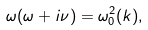<formula> <loc_0><loc_0><loc_500><loc_500>\omega ( \omega + i \nu ) = \omega _ { 0 } ^ { 2 } ( k ) ,</formula> 